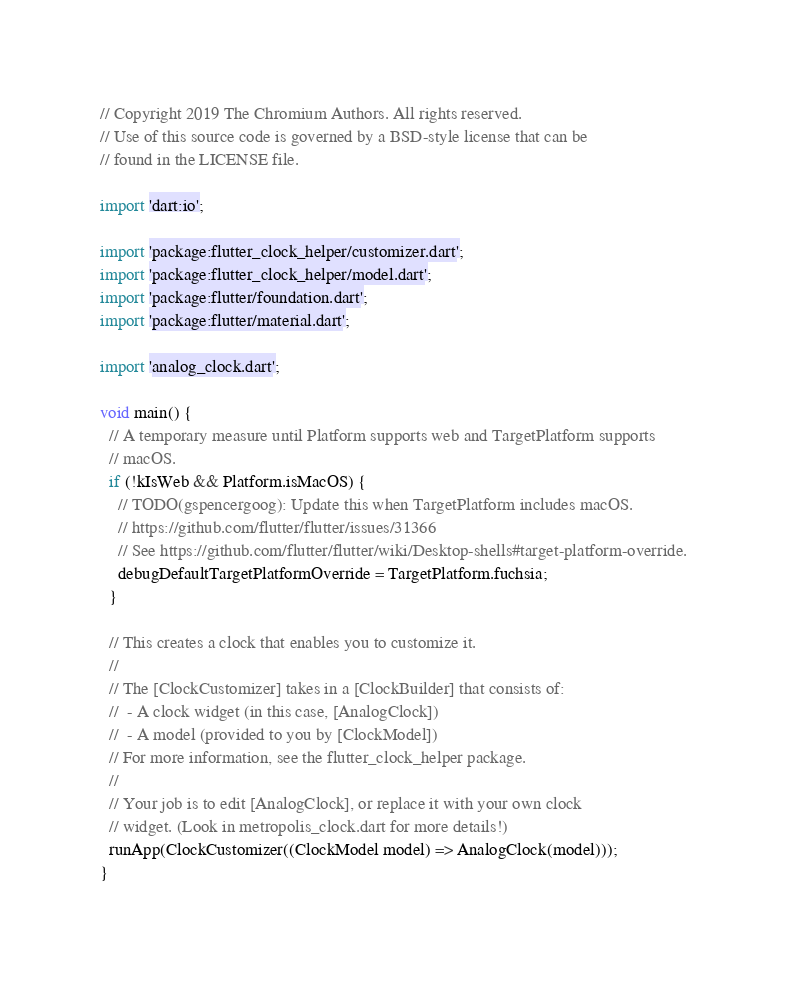Convert code to text. <code><loc_0><loc_0><loc_500><loc_500><_Dart_>// Copyright 2019 The Chromium Authors. All rights reserved.
// Use of this source code is governed by a BSD-style license that can be
// found in the LICENSE file.

import 'dart:io';

import 'package:flutter_clock_helper/customizer.dart';
import 'package:flutter_clock_helper/model.dart';
import 'package:flutter/foundation.dart';
import 'package:flutter/material.dart';

import 'analog_clock.dart';

void main() {
  // A temporary measure until Platform supports web and TargetPlatform supports
  // macOS.
  if (!kIsWeb && Platform.isMacOS) {
    // TODO(gspencergoog): Update this when TargetPlatform includes macOS.
    // https://github.com/flutter/flutter/issues/31366
    // See https://github.com/flutter/flutter/wiki/Desktop-shells#target-platform-override.
    debugDefaultTargetPlatformOverride = TargetPlatform.fuchsia;
  }

  // This creates a clock that enables you to customize it.
  //
  // The [ClockCustomizer] takes in a [ClockBuilder] that consists of:
  //  - A clock widget (in this case, [AnalogClock])
  //  - A model (provided to you by [ClockModel])
  // For more information, see the flutter_clock_helper package.
  //
  // Your job is to edit [AnalogClock], or replace it with your own clock
  // widget. (Look in metropolis_clock.dart for more details!)
  runApp(ClockCustomizer((ClockModel model) => AnalogClock(model)));
}
</code> 